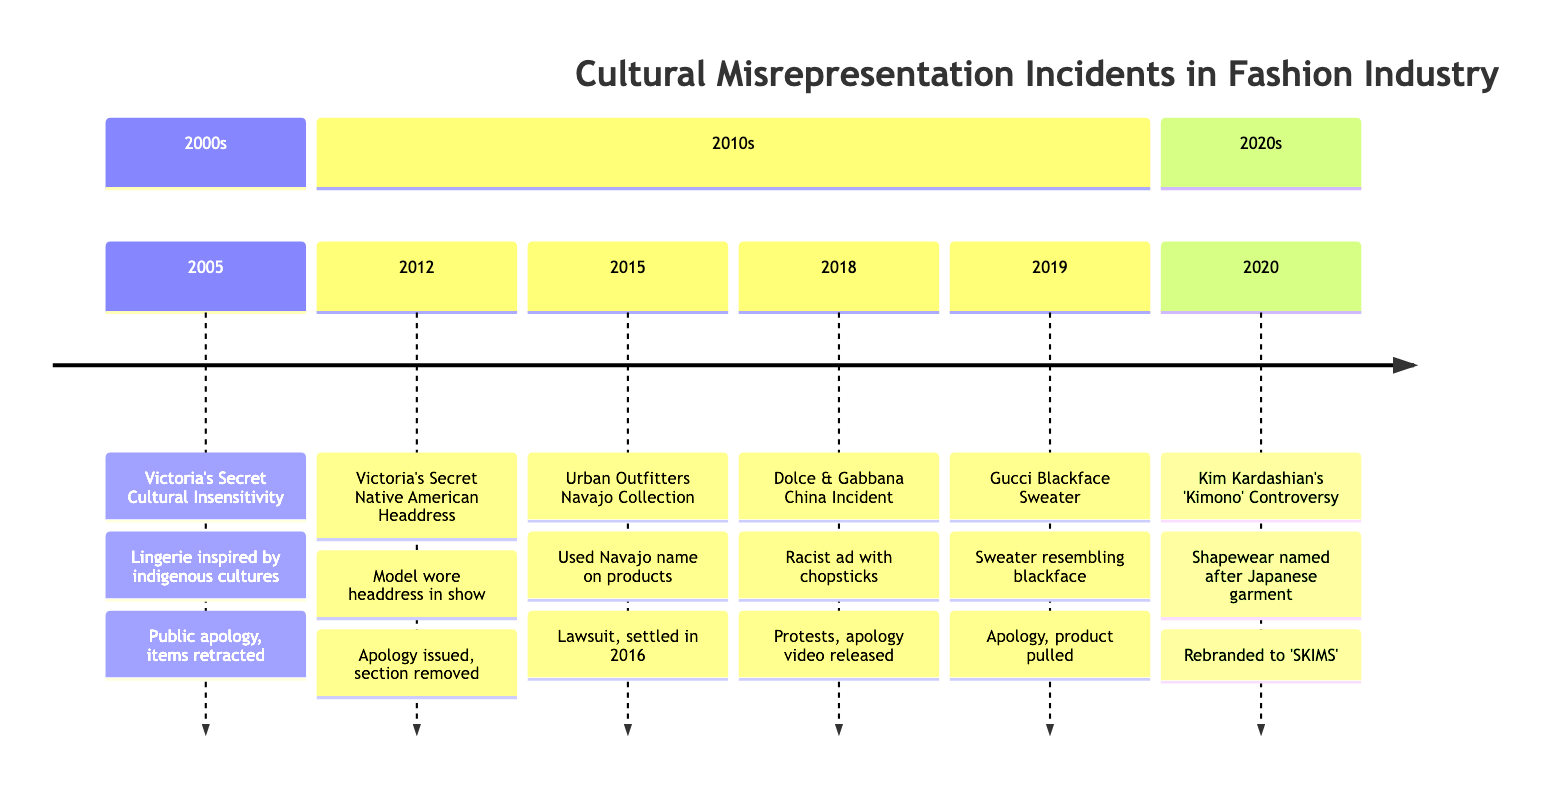What incident took place in 2005? The timeline indicates that in October 2005, Victoria's Secret was involved in a cultural insensitivity incident where lingerie was inspired by indigenous cultures.
Answer: Victoria's Secret Fashion Show Cultural Insensitivity What was the corporate response to the 2018 Dolce & Gabbana incident? Referring back to the timeline for the Dolce & Gabbana incident in September 2018, it mentions that there were public protests, and an apology video from the founders was released in multiple languages.
Answer: Apology video released How many major incidents are listed in the timeline? Counting the individual entries provided in the timeline, there are a total of six incidents outlined from the year 2005 to 2020.
Answer: 6 Which fashion brand faced a lawsuit due to cultural appropriation in 2015? The timeline specifies that Urban Outfitters faced backlash for their Navajo Collection, which led to a lawsuit filed by the Navajo Nation.
Answer: Urban Outfitters What action did Gucci take in response to the blackface sweater scandal in 2019? According to the timeline, Gucci issued an immediate apology, pulled the product from shelves, and committed to improving cultural sensitivity in their design process.
Answer: Pulled the product from shelves In what year did Kim Kardashian's shapewear line get rebranded from 'Kimono'? Based on the timeline, it is stated that the rebranding of Kim Kardashian's shapewear line took place in July 2020, resulting in the new name 'SKIMS.'
Answer: 2020 Which incident involved a model wearing a Native American headdress? The timeline notes that in November 2012, Victoria's Secret was involved in a controversy when a model wore a Native American headdress during their fashion show.
Answer: Victoria's Secret Native American Headdress Controversy What common theme is present in the incidents outlined in the timeline? Analyzing the incidents collectively, they all represent significant instances of cultural misrepresentation and appropriation in the fashion industry, leading to public backlash and corporate apologies or actions.
Answer: Cultural misrepresentation 